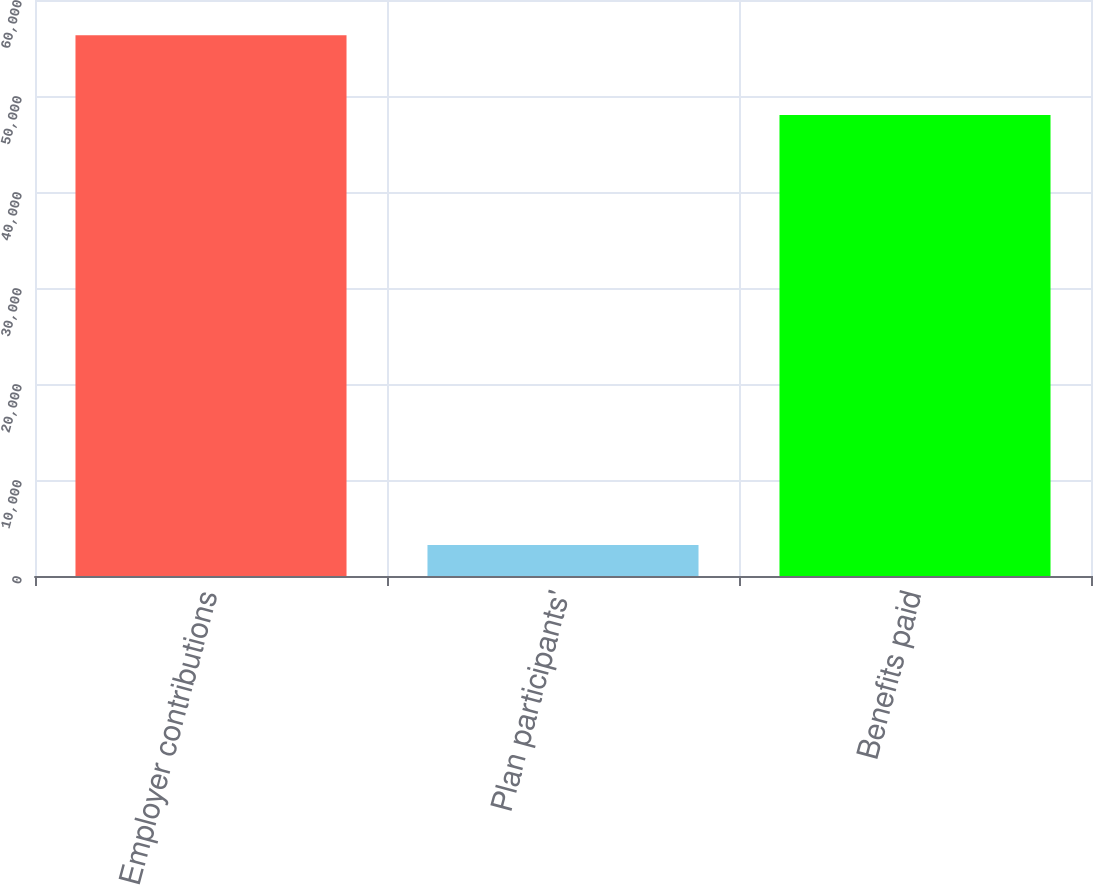<chart> <loc_0><loc_0><loc_500><loc_500><bar_chart><fcel>Employer contributions<fcel>Plan participants'<fcel>Benefits paid<nl><fcel>56328<fcel>3219<fcel>48027<nl></chart> 